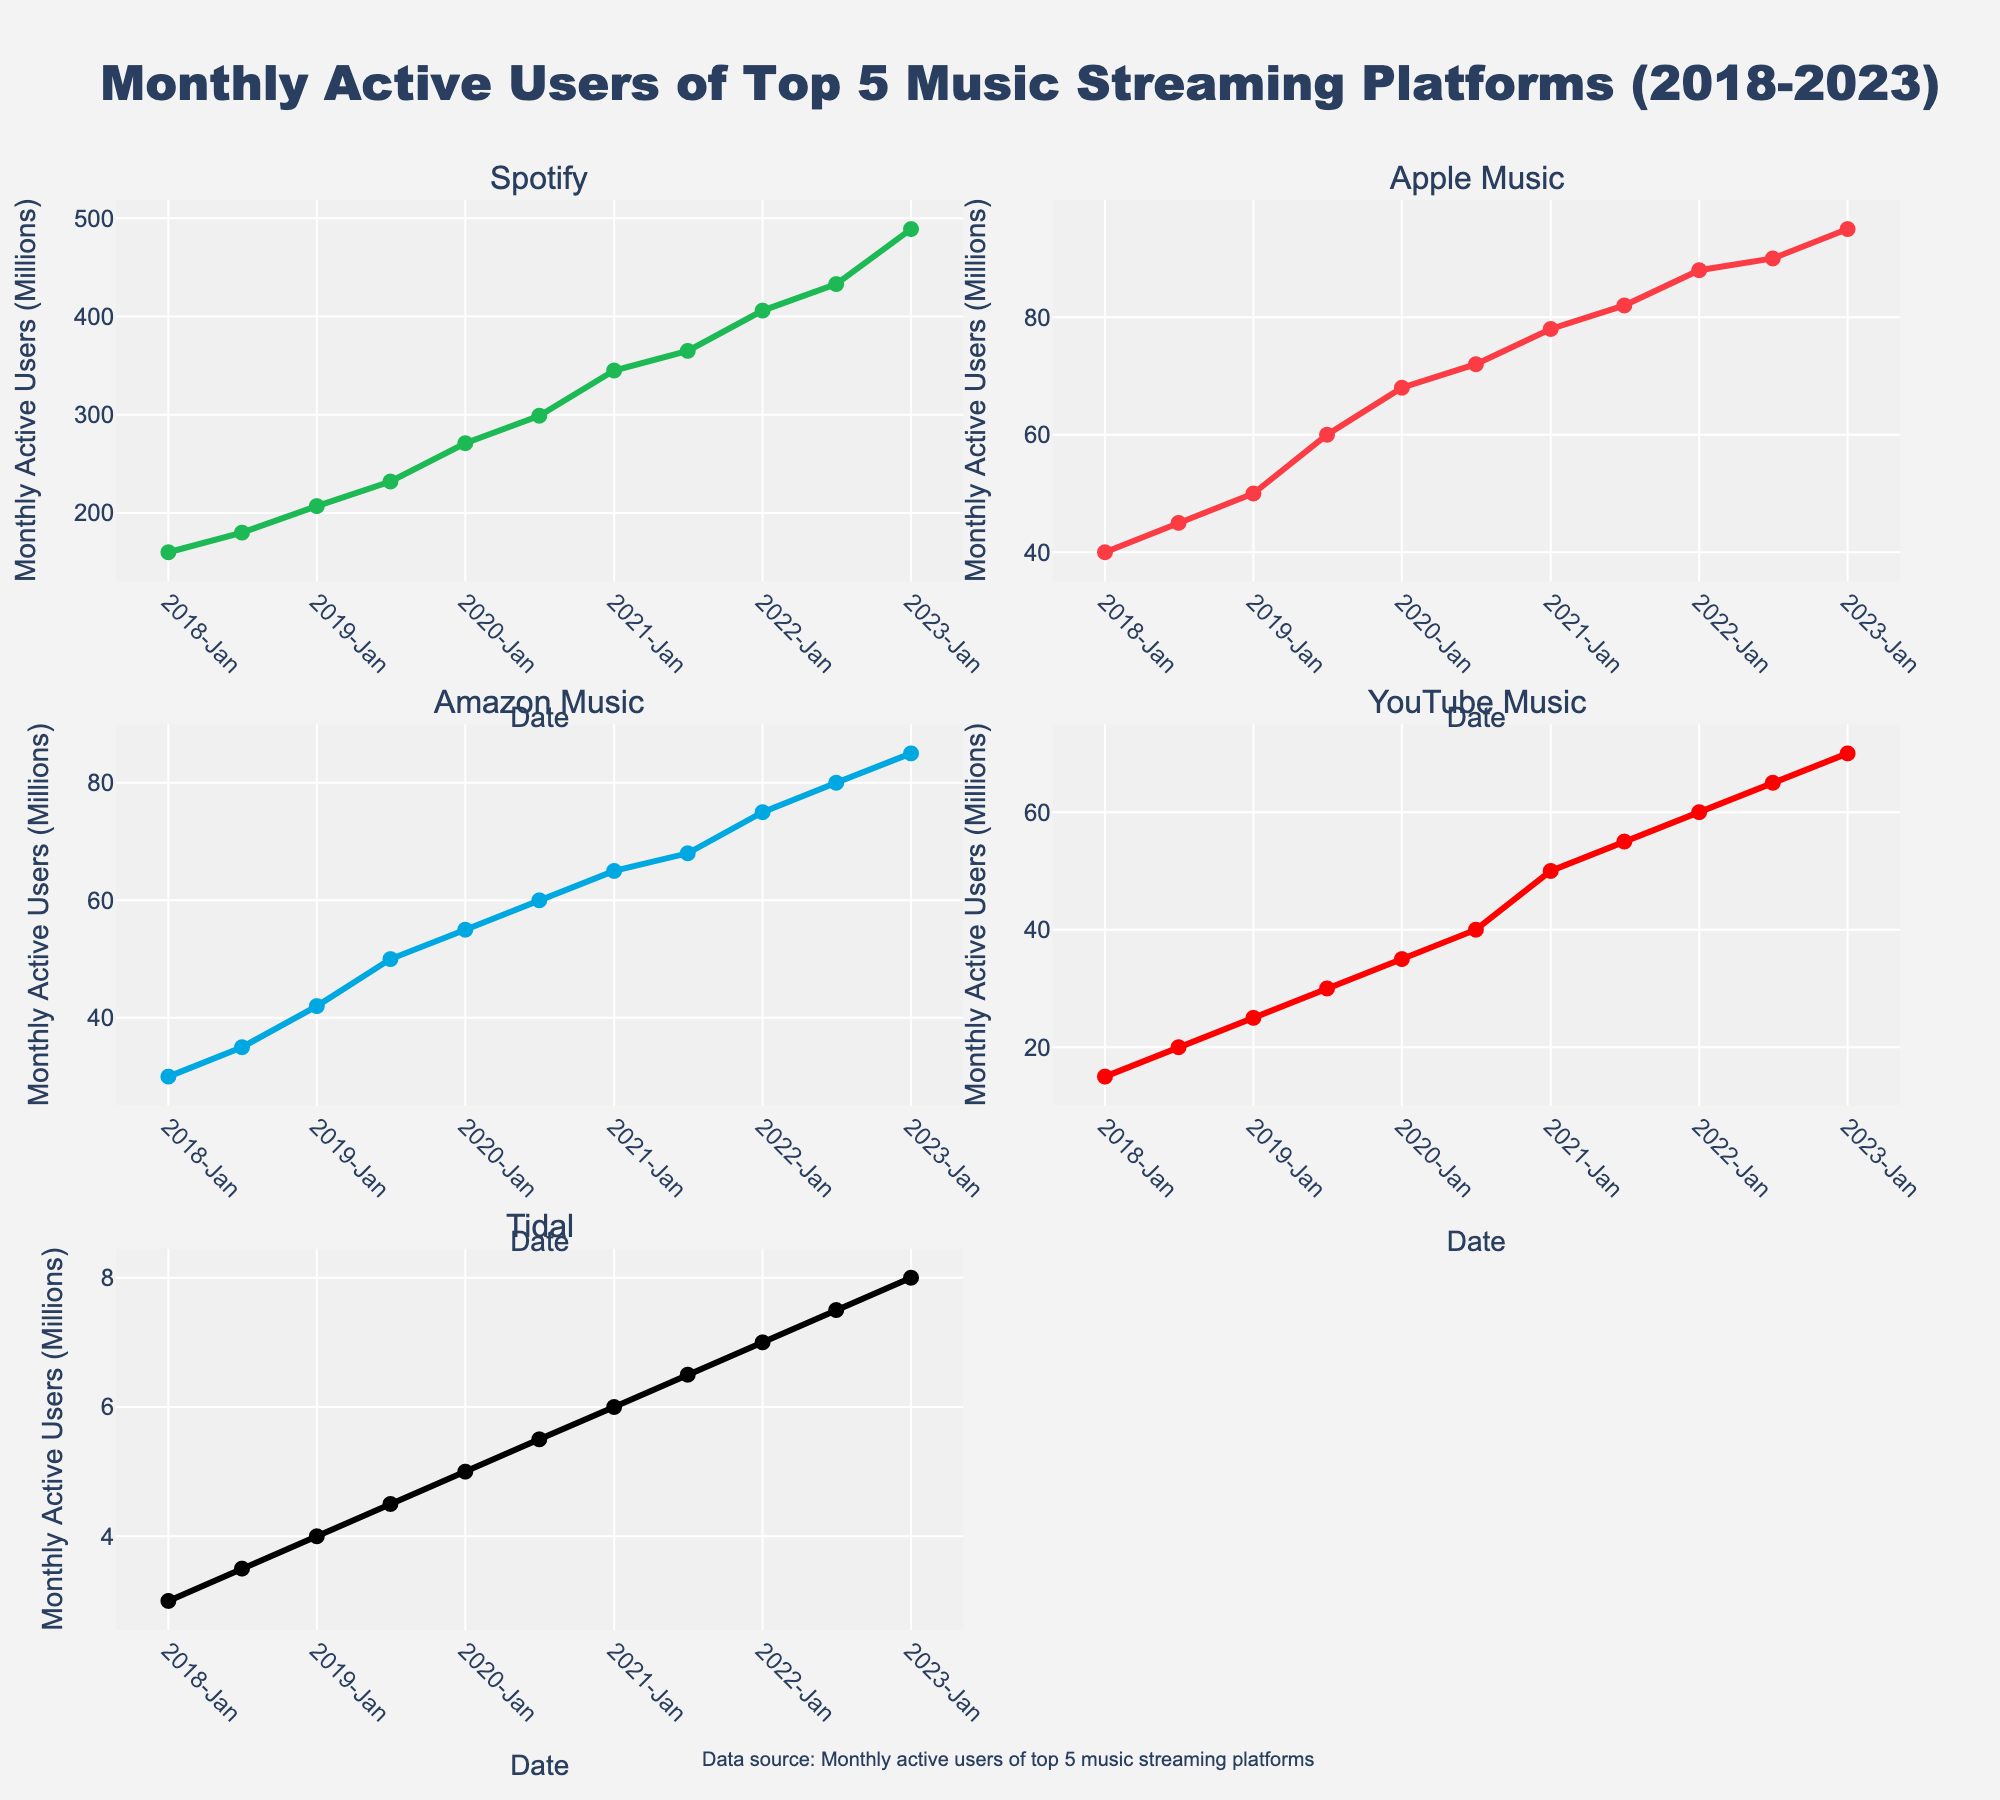When did Apple Music have an active user base over 90 million? By examining the subplot for Apple Music, notice the time axis and trace the point where the user base crosses 90 million.
Answer: July 2022 Which platform had the most consistent growth in monthly active users? Look at the slopes of the lines in each subplot. Consistent growth would have relatively similar increments between data points.
Answer: Spotify What was the increase in monthly active users for YouTube Music from January 2021 to July 2022? Identify the data points for January 2021 and July 2022 on the YouTube Music subplot and subtract the former from the latter (55 million - 50 million).
Answer: 5 million Between January 2020 and July 2020, which platform had the highest growth in monthly active users? Compare the January 2020 and July 2020 data points for each subplot and calculate the increase for each platform.
Answer: Spotify What's the average number of monthly active users for Tidal in 2019? Locate the two data points for Tidal in January and July 2019, sum them (4 + 4.5), and divide by 2.
Answer: 4.25 million Which subplot has the highest peak in monthly active users? Compare the highest values in each subplot. Here, the highest peak can be found simply by analyzing the y-axis.
Answer: Spotify Did Amazon Music ever have more monthly active users than Apple Music during the observation period? Compare the traces of Amazon Music and Apple Music subplots. If Amazon Music's line never goes above Apple Music's line, the answer is no.
Answer: No How did the monthly active users of Tidal change from January 2022 to July 2023? Identify and compare the data points on the Tidal subplot. There's an increase from 7 million to 8 million.
Answer: 1 million increase Which platform saw its first significant uptick in monthly active users in 2019? Study the subplots and locate the year 2019; look for an abrupt increase between January and July 2019 in user numbers.
Answer: Spotify In which year did Spotify’s monthly active user growth rate appear most accelerated? Visually track the steepest incline in the Spotify subplot across the years. The steepest incline represents the highest growth rate.
Answer: 2021 